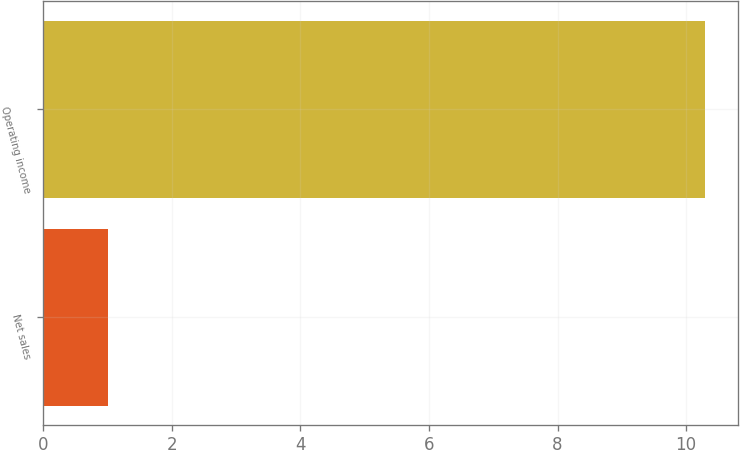Convert chart to OTSL. <chart><loc_0><loc_0><loc_500><loc_500><bar_chart><fcel>Net sales<fcel>Operating income<nl><fcel>1<fcel>10.3<nl></chart> 